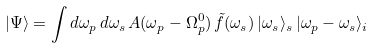Convert formula to latex. <formula><loc_0><loc_0><loc_500><loc_500>| \Psi \rangle = \int d \omega _ { p } \, d \omega _ { s } \, A ( \omega _ { p } - \Omega ^ { 0 } _ { p } ) \, \tilde { f } ( \omega _ { s } ) \, | \omega _ { s } \rangle _ { s } \, | \omega _ { p } - \omega _ { s } \rangle _ { i }</formula> 